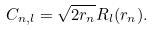Convert formula to latex. <formula><loc_0><loc_0><loc_500><loc_500>C _ { n , l } = \sqrt { 2 r _ { n } } R _ { l } ( r _ { n } ) .</formula> 